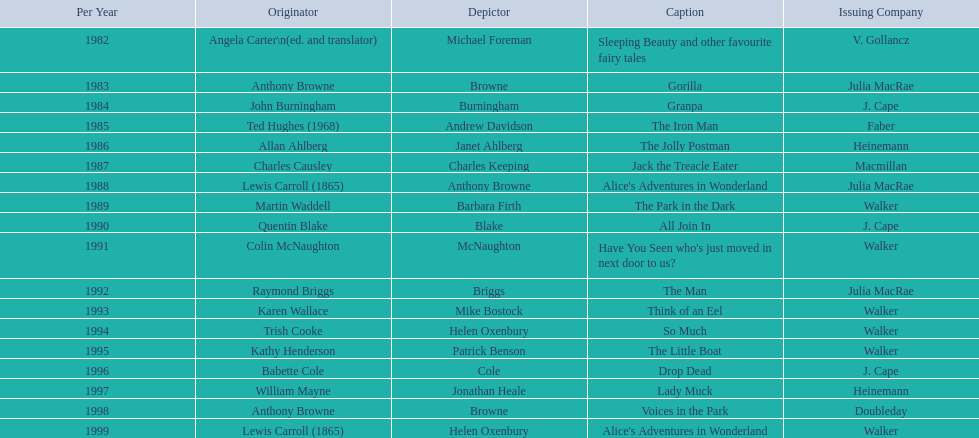Can you parse all the data within this table? {'header': ['Per Year', 'Originator', 'Depictor', 'Caption', 'Issuing Company'], 'rows': [['1982', 'Angela Carter\\n(ed. and translator)', 'Michael Foreman', 'Sleeping Beauty and other favourite fairy tales', 'V. Gollancz'], ['1983', 'Anthony Browne', 'Browne', 'Gorilla', 'Julia MacRae'], ['1984', 'John Burningham', 'Burningham', 'Granpa', 'J. Cape'], ['1985', 'Ted Hughes (1968)', 'Andrew Davidson', 'The Iron Man', 'Faber'], ['1986', 'Allan Ahlberg', 'Janet Ahlberg', 'The Jolly Postman', 'Heinemann'], ['1987', 'Charles Causley', 'Charles Keeping', 'Jack the Treacle Eater', 'Macmillan'], ['1988', 'Lewis Carroll (1865)', 'Anthony Browne', "Alice's Adventures in Wonderland", 'Julia MacRae'], ['1989', 'Martin Waddell', 'Barbara Firth', 'The Park in the Dark', 'Walker'], ['1990', 'Quentin Blake', 'Blake', 'All Join In', 'J. Cape'], ['1991', 'Colin McNaughton', 'McNaughton', "Have You Seen who's just moved in next door to us?", 'Walker'], ['1992', 'Raymond Briggs', 'Briggs', 'The Man', 'Julia MacRae'], ['1993', 'Karen Wallace', 'Mike Bostock', 'Think of an Eel', 'Walker'], ['1994', 'Trish Cooke', 'Helen Oxenbury', 'So Much', 'Walker'], ['1995', 'Kathy Henderson', 'Patrick Benson', 'The Little Boat', 'Walker'], ['1996', 'Babette Cole', 'Cole', 'Drop Dead', 'J. Cape'], ['1997', 'William Mayne', 'Jonathan Heale', 'Lady Muck', 'Heinemann'], ['1998', 'Anthony Browne', 'Browne', 'Voices in the Park', 'Doubleday'], ['1999', 'Lewis Carroll (1865)', 'Helen Oxenbury', "Alice's Adventures in Wonderland", 'Walker']]} How many total titles were published by walker? 5. 